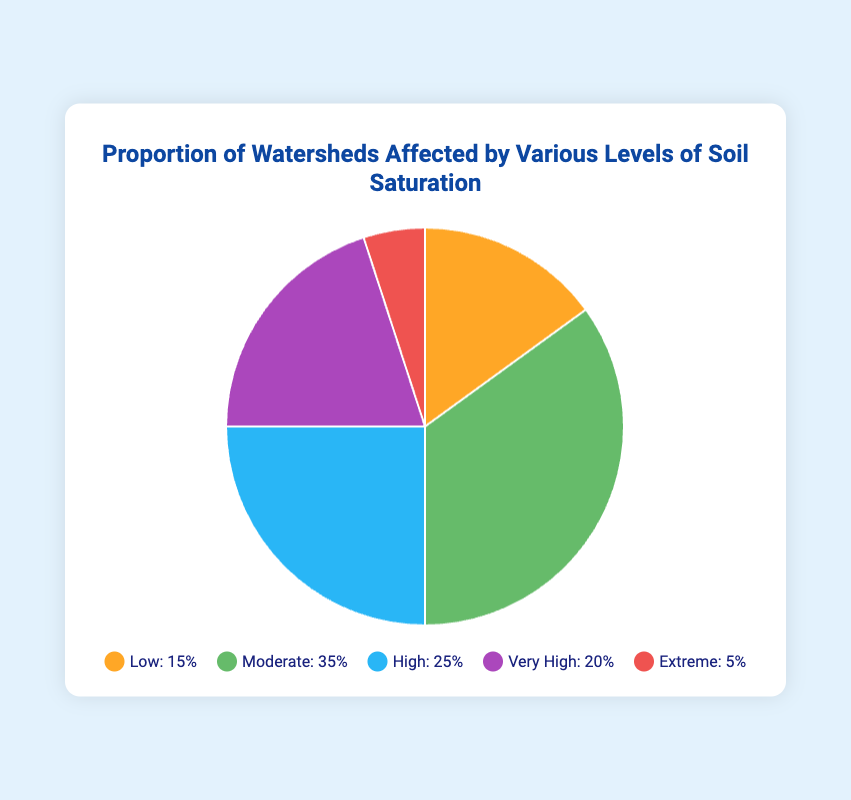What percentage of watersheds are affected by moderate soil saturation? The slice labeled "Moderate" in the pie chart represents this data point. According to the chart, the percentage of watersheds affected by moderate soil saturation is 35%.
Answer: 35% How does the percentage of watersheds affected by high soil saturation compare to those with low soil saturation? The pie chart shows that high soil saturation affects 25% of watersheds and low soil saturation affects 15%. Comparing these, high soil saturation affects 10% more watersheds than low soil saturation.
Answer: 10% Which soil saturation category affects the smallest portion of watersheds? The pie chart indicates the smallest portion by the slice representing 5%, which is labeled "Extreme".
Answer: Extreme What is the combined percentage of watersheds affected by high and very high soil saturation levels? The "High" and "Very High" slices in the pie chart represent 25% and 20% respectively. Adding these percentages together, the combined percentage is 25% + 20% = 45%.
Answer: 45% Is the proportion of watersheds affected by very high soil saturation greater than the proportion affected by extreme soil saturation? By how much? The pie chart shows that very high soil saturation affects 20% of watersheds while extreme soil saturation affects 5%. Very high soil saturation affects 15% more watersheds than extreme soil saturation.
Answer: 15% What proportion of watersheds is affected by either low or extreme soil saturation? The slices labeled "Low" and "Extreme" in the pie chart represent 15% and 5% respectively. Adding these percentages together, the combined proportion is 15% + 5% = 20%.
Answer: 20% Which category has the second highest percentage of watersheds affected? The pie chart shows "Moderate" with 35%, "High" with 25%, "Very High" with 20%, and "Low" with 15%. The second highest percentage, therefore, is the "High" category with 25%.
Answer: High How many more watersheds are affected by moderate soil saturation compared to those affected by extreme soil saturation? Moderate soil saturation affects 35% of watersheds, and extreme affects 5%. The difference is 35% - 5% = 30%. Therefore, 30% more watersheds are affected by moderate soil saturation.
Answer: 30% What's the average percentage of watersheds affected by the various levels of soil saturation? There are five levels: Low (15%), Moderate (35%), High (25%), Very High (20%), and Extreme (5%). The average is calculated by summing these percentages and dividing by the number of categories: (15% + 35% + 25% + 20% + 5%)/5 = 20%.
Answer: 20% 